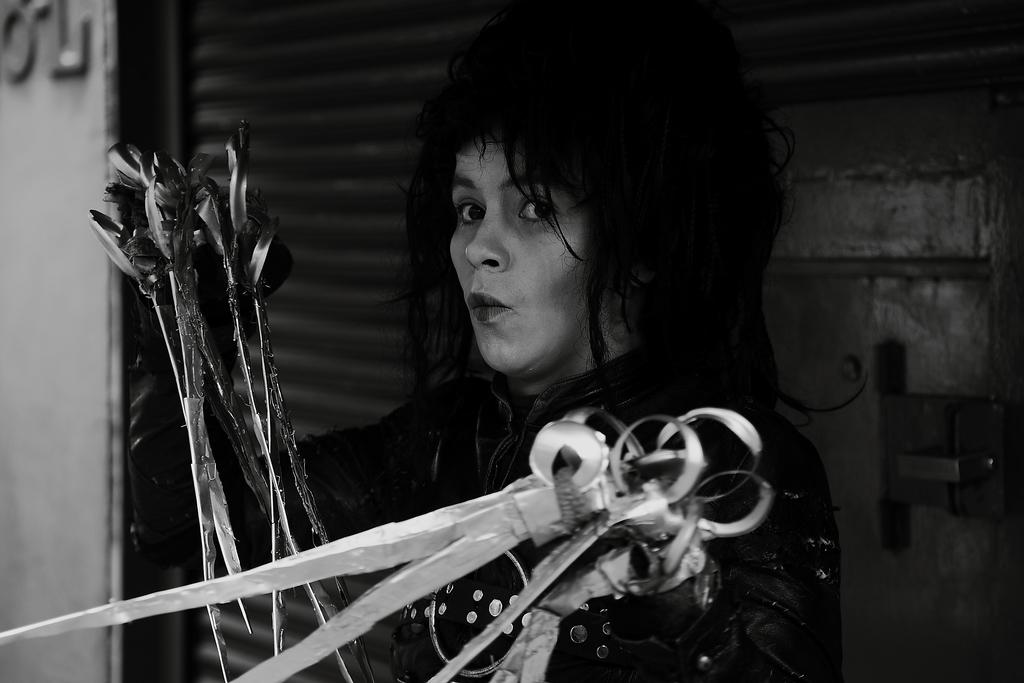Who is the main subject in the image? There is a person in the center of the image. What is the person holding in their hands? The person is holding arrows and swords. What can be seen in the background of the image? There is a door and a wall in the background of the image. What type of pet can be seen playing with a clover in the image? There is no pet or clover present in the image; it features a person holding arrows and swords with a door and a wall in the background. Is there any bread visible in the image? No, there is no bread present in the image. 